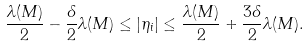<formula> <loc_0><loc_0><loc_500><loc_500>\frac { \lambda ( M ) } { 2 } - \frac { \delta } { 2 } \lambda ( M ) \leq | \eta _ { i } | \leq \frac { \lambda ( M ) } { 2 } + \frac { 3 \delta } { 2 } \lambda ( M ) .</formula> 